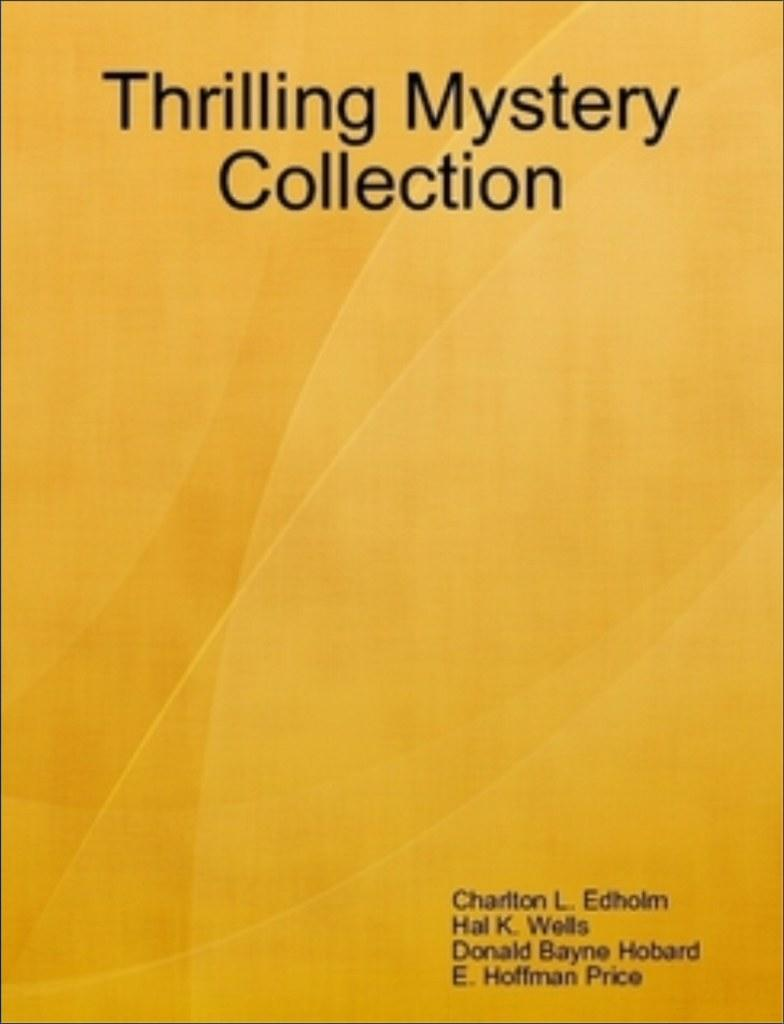<image>
Provide a brief description of the given image. the cover of a page that says 'thrilling mystery collection' on it 